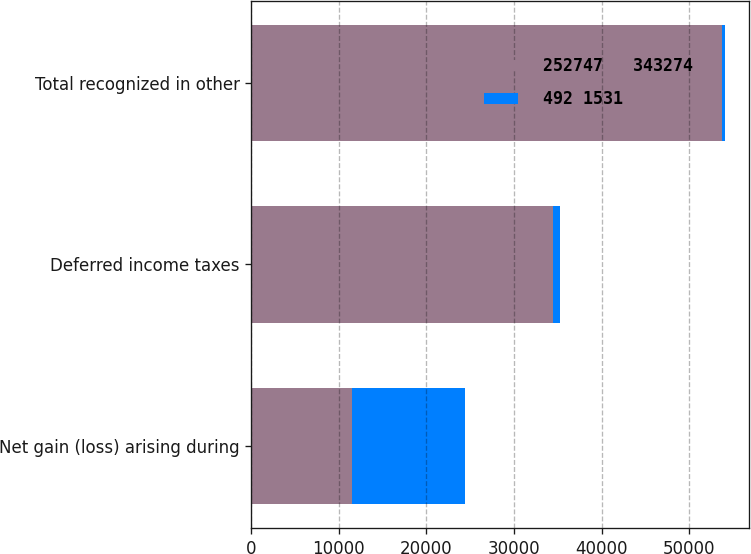Convert chart. <chart><loc_0><loc_0><loc_500><loc_500><stacked_bar_chart><ecel><fcel>Net gain (loss) arising during<fcel>Deferred income taxes<fcel>Total recognized in other<nl><fcel>252747   343274<fcel>11465<fcel>34417<fcel>53699<nl><fcel>492 1531<fcel>12911<fcel>816<fcel>431<nl></chart> 